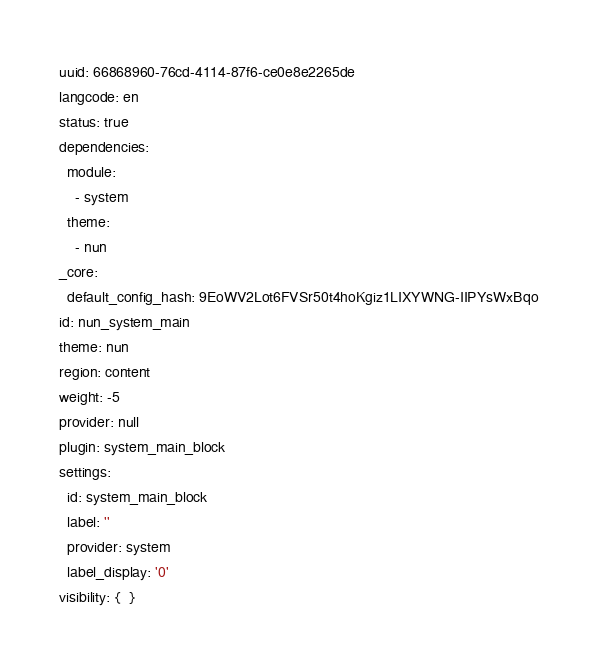Convert code to text. <code><loc_0><loc_0><loc_500><loc_500><_YAML_>uuid: 66868960-76cd-4114-87f6-ce0e8e2265de
langcode: en
status: true
dependencies:
  module:
    - system
  theme:
    - nun
_core:
  default_config_hash: 9EoWV2Lot6FVSr50t4hoKgiz1LIXYWNG-IIPYsWxBqo
id: nun_system_main
theme: nun
region: content
weight: -5
provider: null
plugin: system_main_block
settings:
  id: system_main_block
  label: ''
  provider: system
  label_display: '0'
visibility: {  }
</code> 